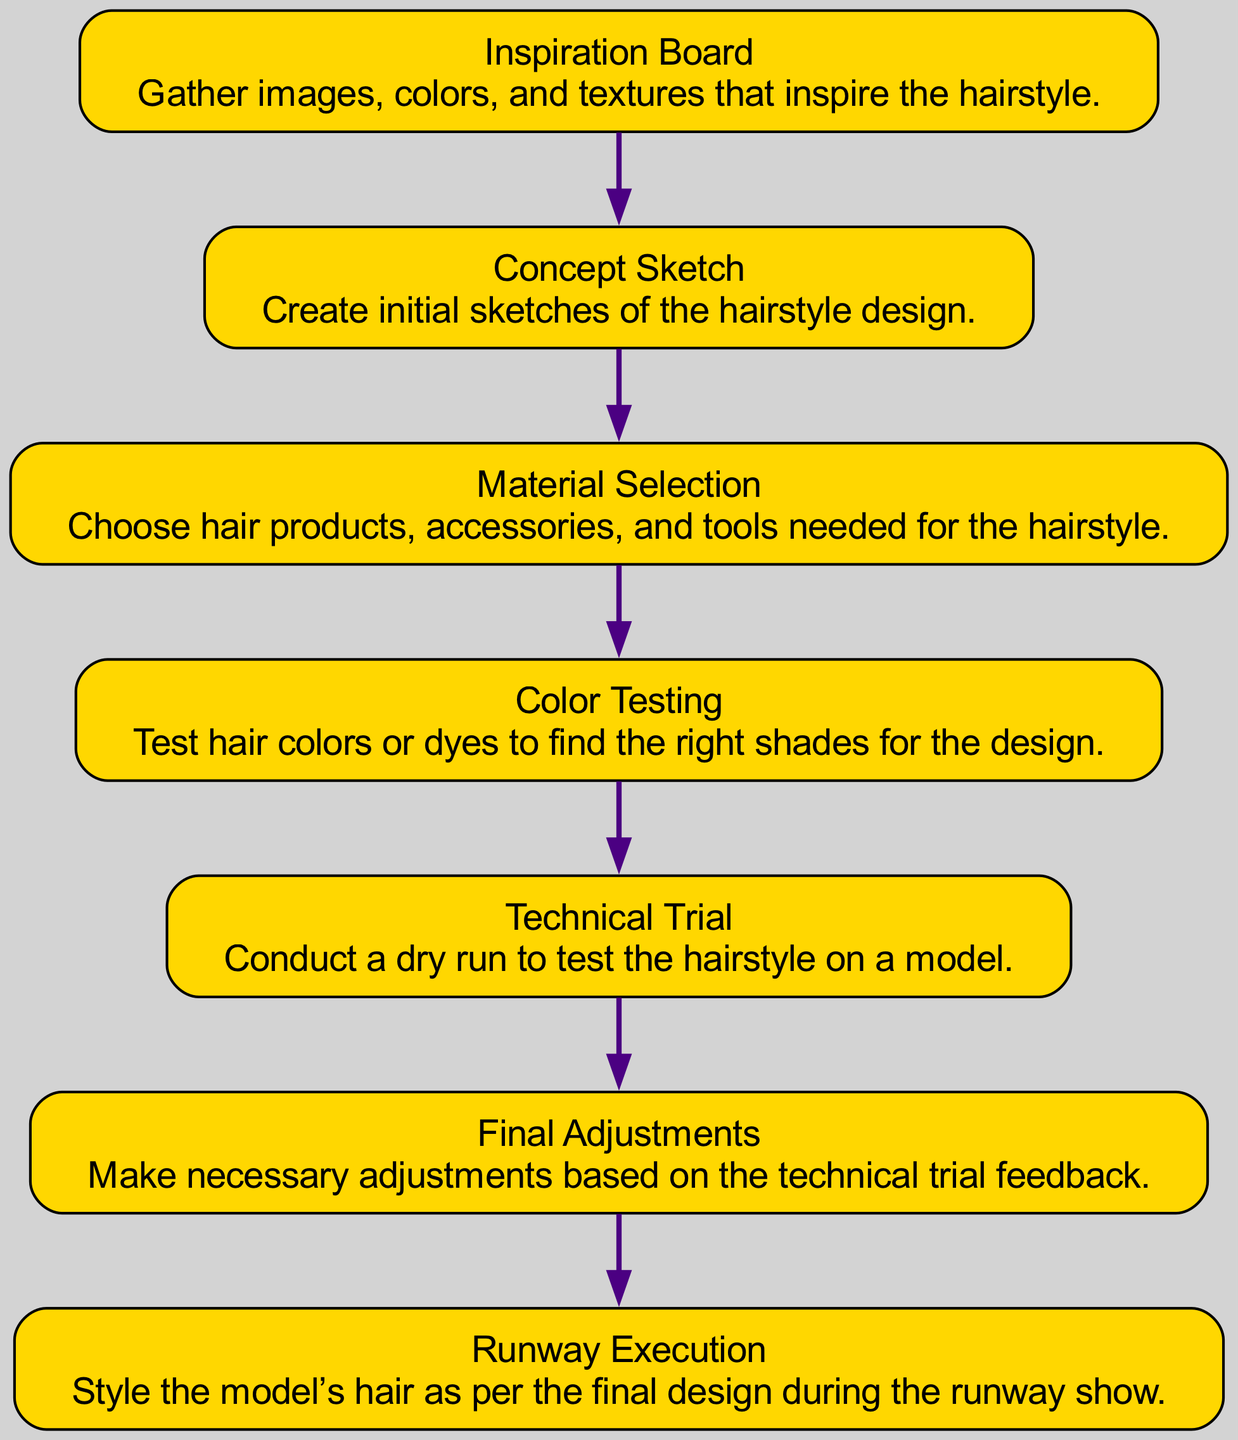What is the first step in creating a bold hairstyle? The first step in the process is the "Inspiration Board," where images, colors, and textures that inspire the hairstyle are gathered.
Answer: Inspiration Board How many nodes are in the diagram? The diagram contains a total of seven nodes, each representing a step in the process of creating a bold hairstyle.
Answer: 7 Which step follows the "Material Selection"? After "Material Selection," the next step is "Color Testing," which involves testing hair colors or dyes to find the right shades for the design.
Answer: Color Testing What is the last step of the process? The final step of the process is "Runway Execution," where the model’s hair is styled according to the final design during the runway show.
Answer: Runway Execution What edge connects "Concept Sketch" to "Material Selection"? The edge connecting "Concept Sketch" to "Material Selection" indicates the progression from creating initial sketches of the hairstyle design to choosing the hair products, accessories, and tools needed for the hairstyle.
Answer: Material Selection How many edges are present in the diagram? There are six edges in the diagram, which represent the connections between the seven nodes in a linear sequence.
Answer: 6 Which two steps are directly linked by an edge? The two steps directly linked by an edge are "Technical Trial" and "Final Adjustments," indicating that feedback from the technical trial leads to adjustments in the hairstyle.
Answer: Technical Trial and Final Adjustments Which step involves testing hair colors? The step that involves testing hair colors is called "Color Testing," where various shades are evaluated to match the design.
Answer: Color Testing What is the purpose of the "Final Adjustments" step? The purpose of the "Final Adjustments" step is to make necessary changes based on the feedback received from the technical trial conducted earlier.
Answer: Make necessary adjustments 